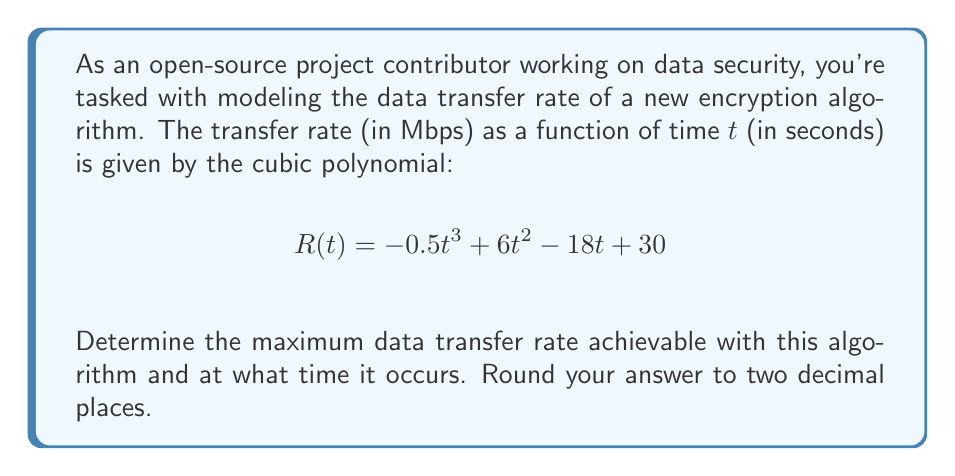Provide a solution to this math problem. To find the maximum data transfer rate, we need to follow these steps:

1) The maximum of a function occurs at a critical point where the first derivative is zero or undefined. Let's find the first derivative of $R(t)$:

   $$R'(t) = -1.5t^2 + 12t - 18$$

2) Set $R'(t) = 0$ and solve for t:

   $$-1.5t^2 + 12t - 18 = 0$$

3) This is a quadratic equation. We can solve it using the quadratic formula:
   
   $$t = \frac{-b \pm \sqrt{b^2 - 4ac}}{2a}$$

   Where $a = -1.5$, $b = 12$, and $c = -18$

4) Plugging in these values:

   $$t = \frac{-12 \pm \sqrt{12^2 - 4(-1.5)(-18)}}{2(-1.5)}$$
   
   $$= \frac{-12 \pm \sqrt{144 - 108}}{-3}$$
   
   $$= \frac{-12 \pm \sqrt{36}}{-3}$$
   
   $$= \frac{-12 \pm 6}{-3}$$

5) This gives us two solutions:

   $$t_1 = \frac{-12 + 6}{-3} = 2$$
   
   $$t_2 = \frac{-12 - 6}{-3} = 6$$

6) To determine which of these gives the maximum, we can check the second derivative:

   $$R''(t) = -3t + 12$$

7) At $t = 2$: $R''(2) = -3(2) + 12 = 6 > 0$, indicating a local minimum
   At $t = 6$: $R''(6) = -3(6) + 12 = -6 < 0$, indicating a local maximum

8) Therefore, the maximum occurs at $t = 6$ seconds.

9) To find the maximum rate, we plug $t = 6$ into our original function:

   $$R(6) = -0.5(6)^3 + 6(6)^2 - 18(6) + 30$$
   
   $$= -108 + 216 - 108 + 30$$
   
   $$= 30$$ Mbps
Answer: The maximum data transfer rate is 30.00 Mbps, occurring at t = 6.00 seconds. 